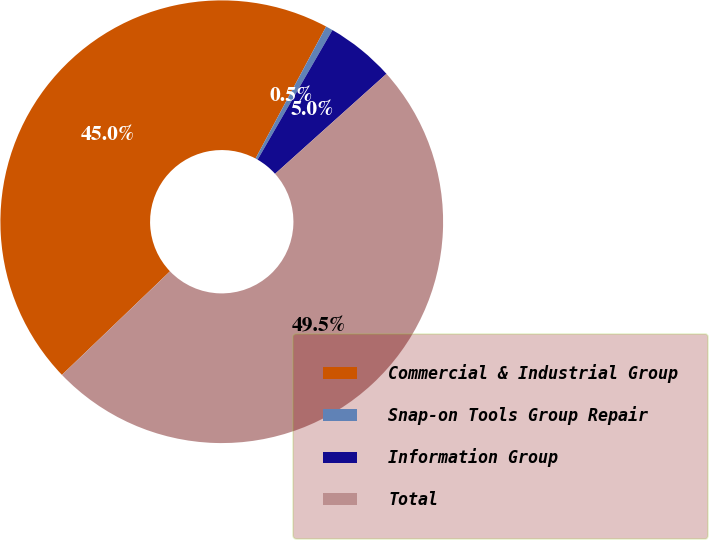Convert chart. <chart><loc_0><loc_0><loc_500><loc_500><pie_chart><fcel>Commercial & Industrial Group<fcel>Snap-on Tools Group Repair<fcel>Information Group<fcel>Total<nl><fcel>44.98%<fcel>0.52%<fcel>5.02%<fcel>49.48%<nl></chart> 